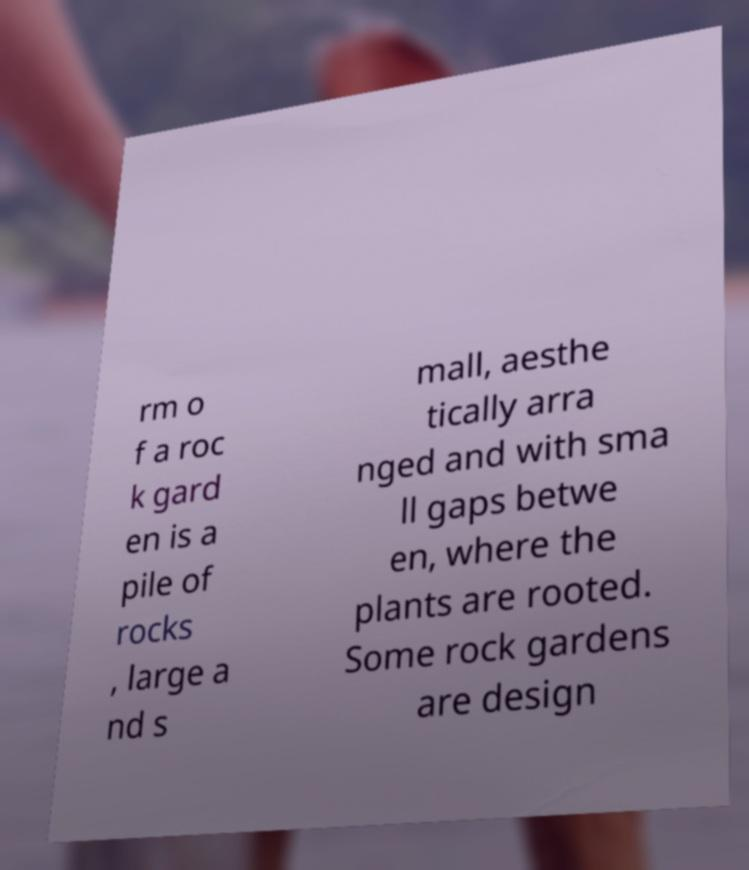What messages or text are displayed in this image? I need them in a readable, typed format. rm o f a roc k gard en is a pile of rocks , large a nd s mall, aesthe tically arra nged and with sma ll gaps betwe en, where the plants are rooted. Some rock gardens are design 